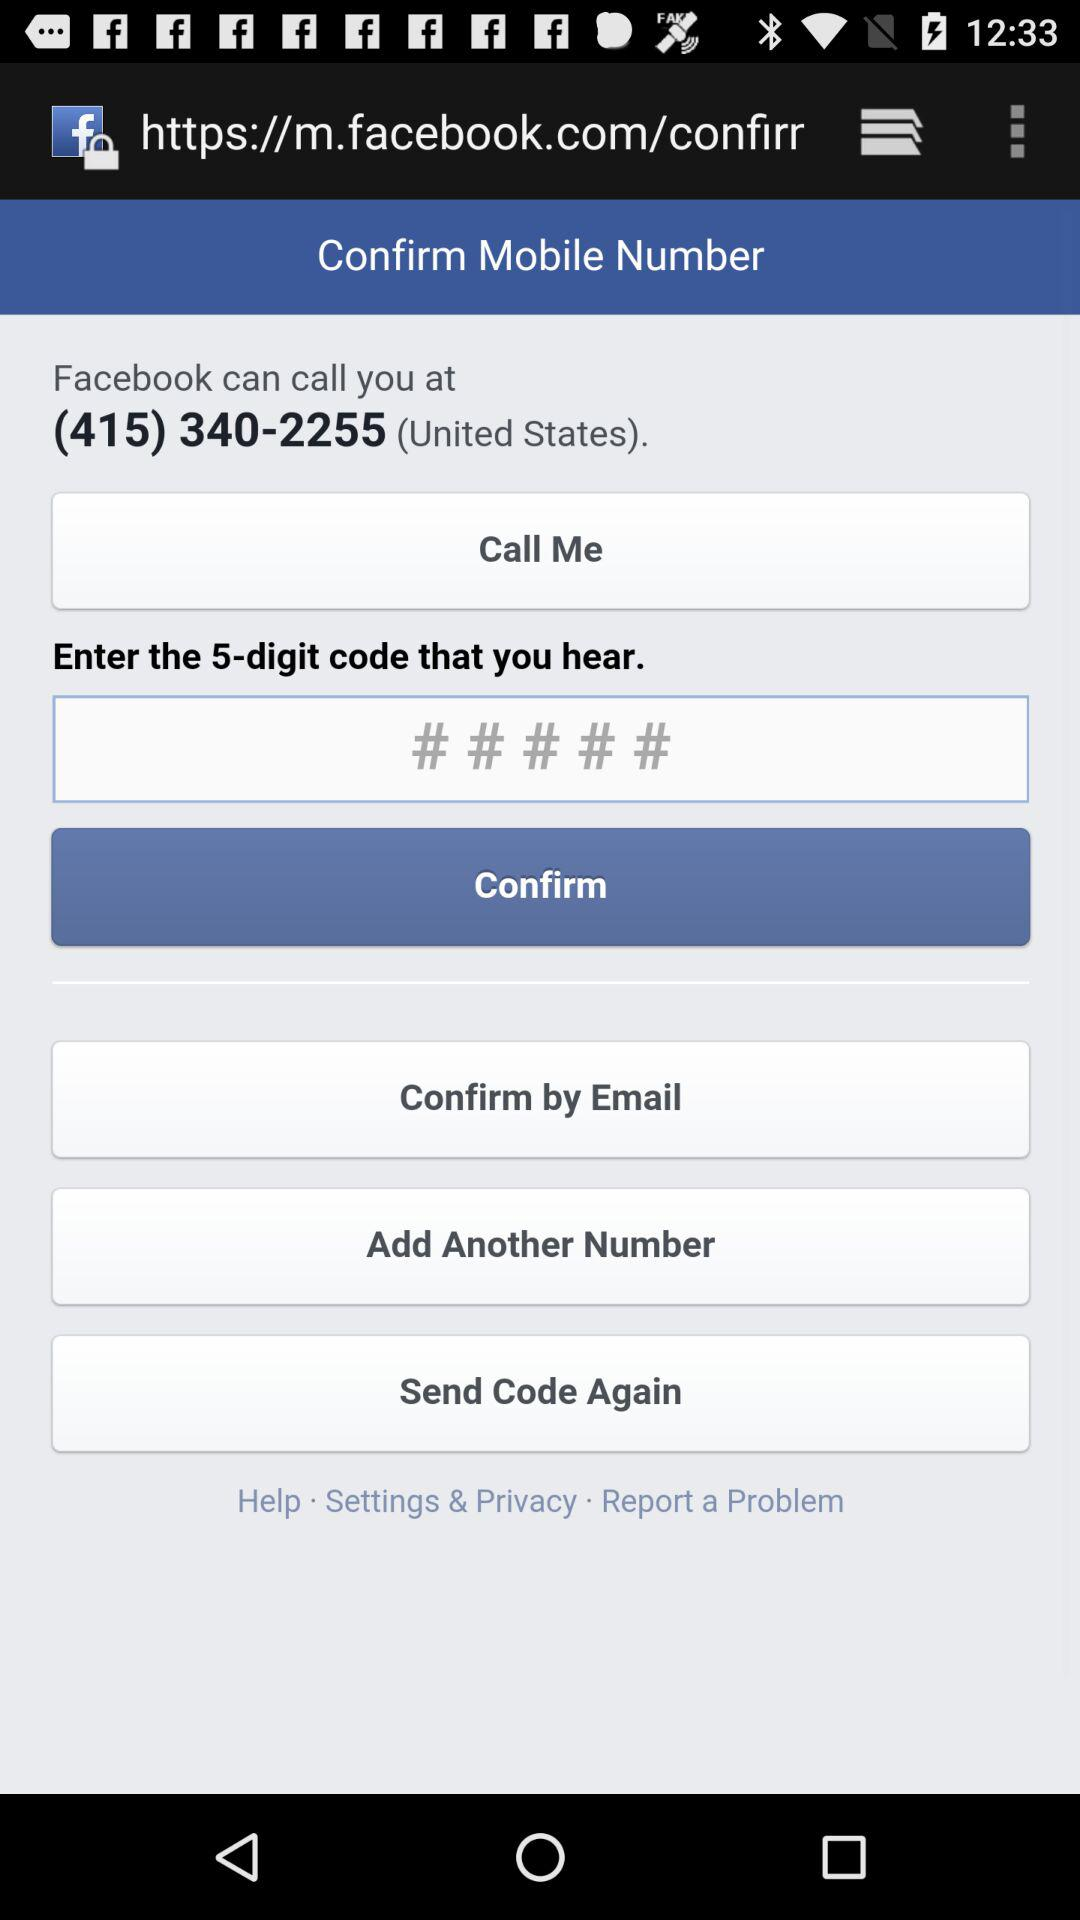What is the number to be called by Facebook? The number is (415) 340-2255. 